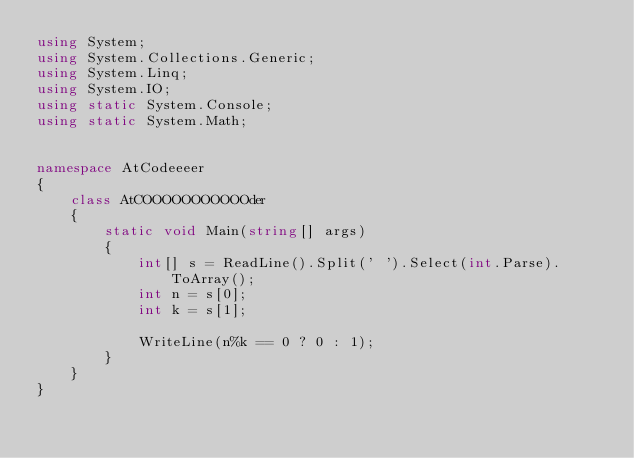<code> <loc_0><loc_0><loc_500><loc_500><_C#_>using System;
using System.Collections.Generic;
using System.Linq;
using System.IO;
using static System.Console;
using static System.Math;


namespace AtCodeeeer
{
    class AtCOOOOOOOOOOOder
    {
        static void Main(string[] args)
        {
            int[] s = ReadLine().Split(' ').Select(int.Parse).ToArray();
            int n = s[0];
            int k = s[1];

            WriteLine(n%k == 0 ? 0 : 1);
        }
    }
}
</code> 